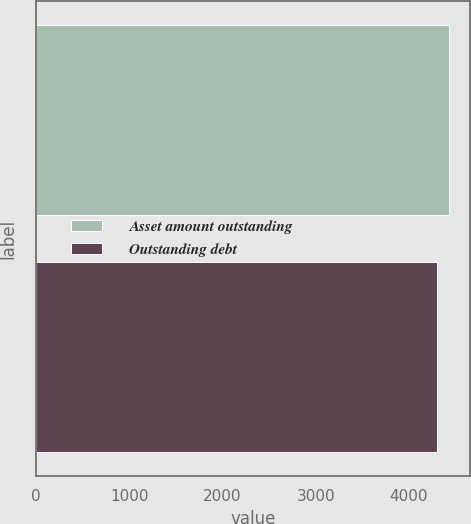<chart> <loc_0><loc_0><loc_500><loc_500><bar_chart><fcel>Asset amount outstanding<fcel>Outstanding debt<nl><fcel>4433<fcel>4301<nl></chart> 